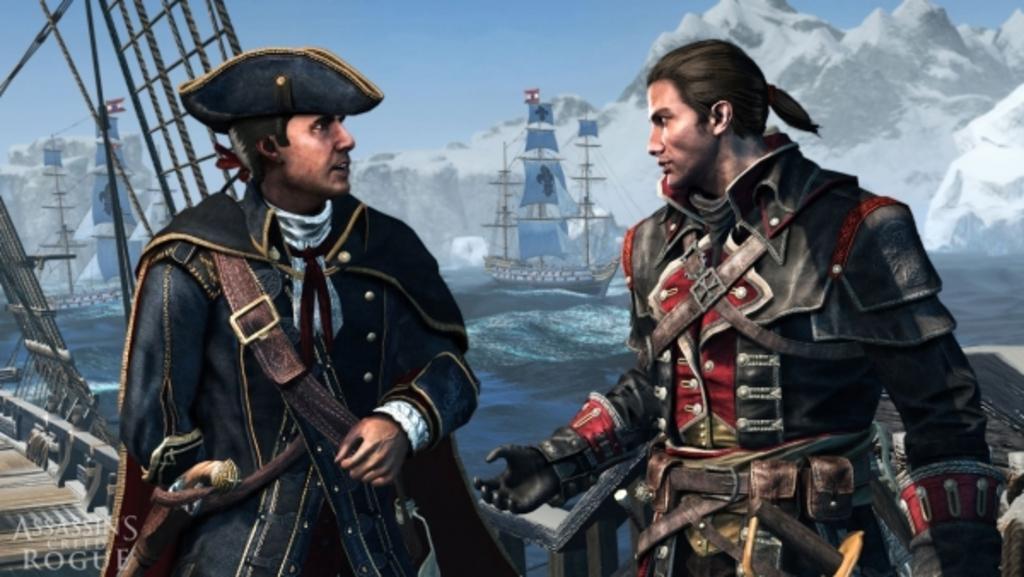Could you give a brief overview of what you see in this image? As we can see in the image there are two people, bridgewater, boat and hills. On the top there is sky. 